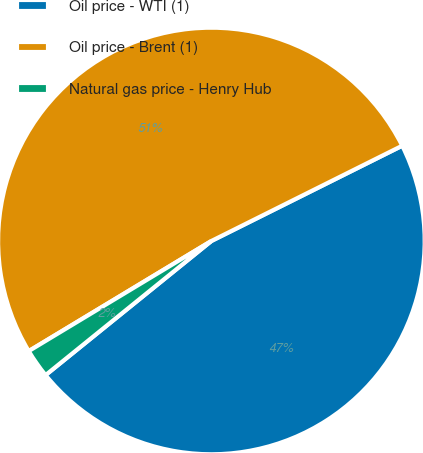<chart> <loc_0><loc_0><loc_500><loc_500><pie_chart><fcel>Oil price - WTI (1)<fcel>Oil price - Brent (1)<fcel>Natural gas price - Henry Hub<nl><fcel>46.55%<fcel>51.27%<fcel>2.19%<nl></chart> 